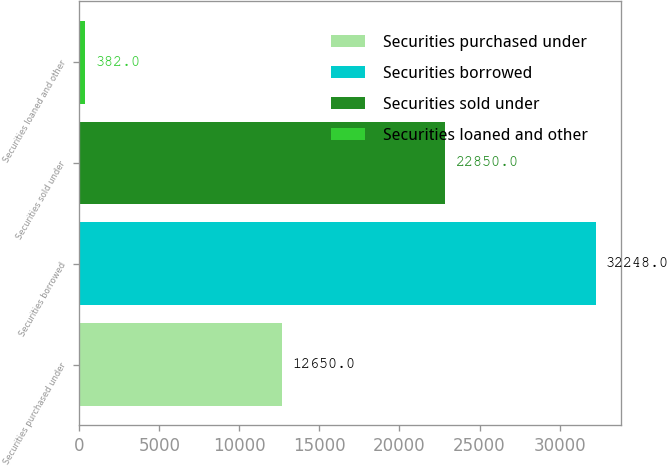<chart> <loc_0><loc_0><loc_500><loc_500><bar_chart><fcel>Securities purchased under<fcel>Securities borrowed<fcel>Securities sold under<fcel>Securities loaned and other<nl><fcel>12650<fcel>32248<fcel>22850<fcel>382<nl></chart> 